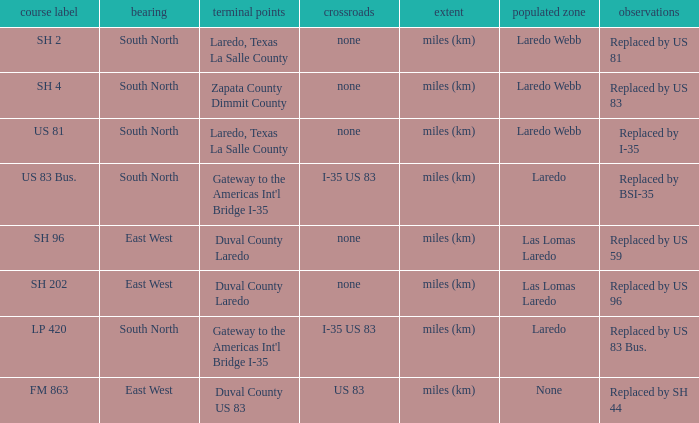What unit of length is being used for the route with "replaced by us 81" in their remarks section? Miles (km). 